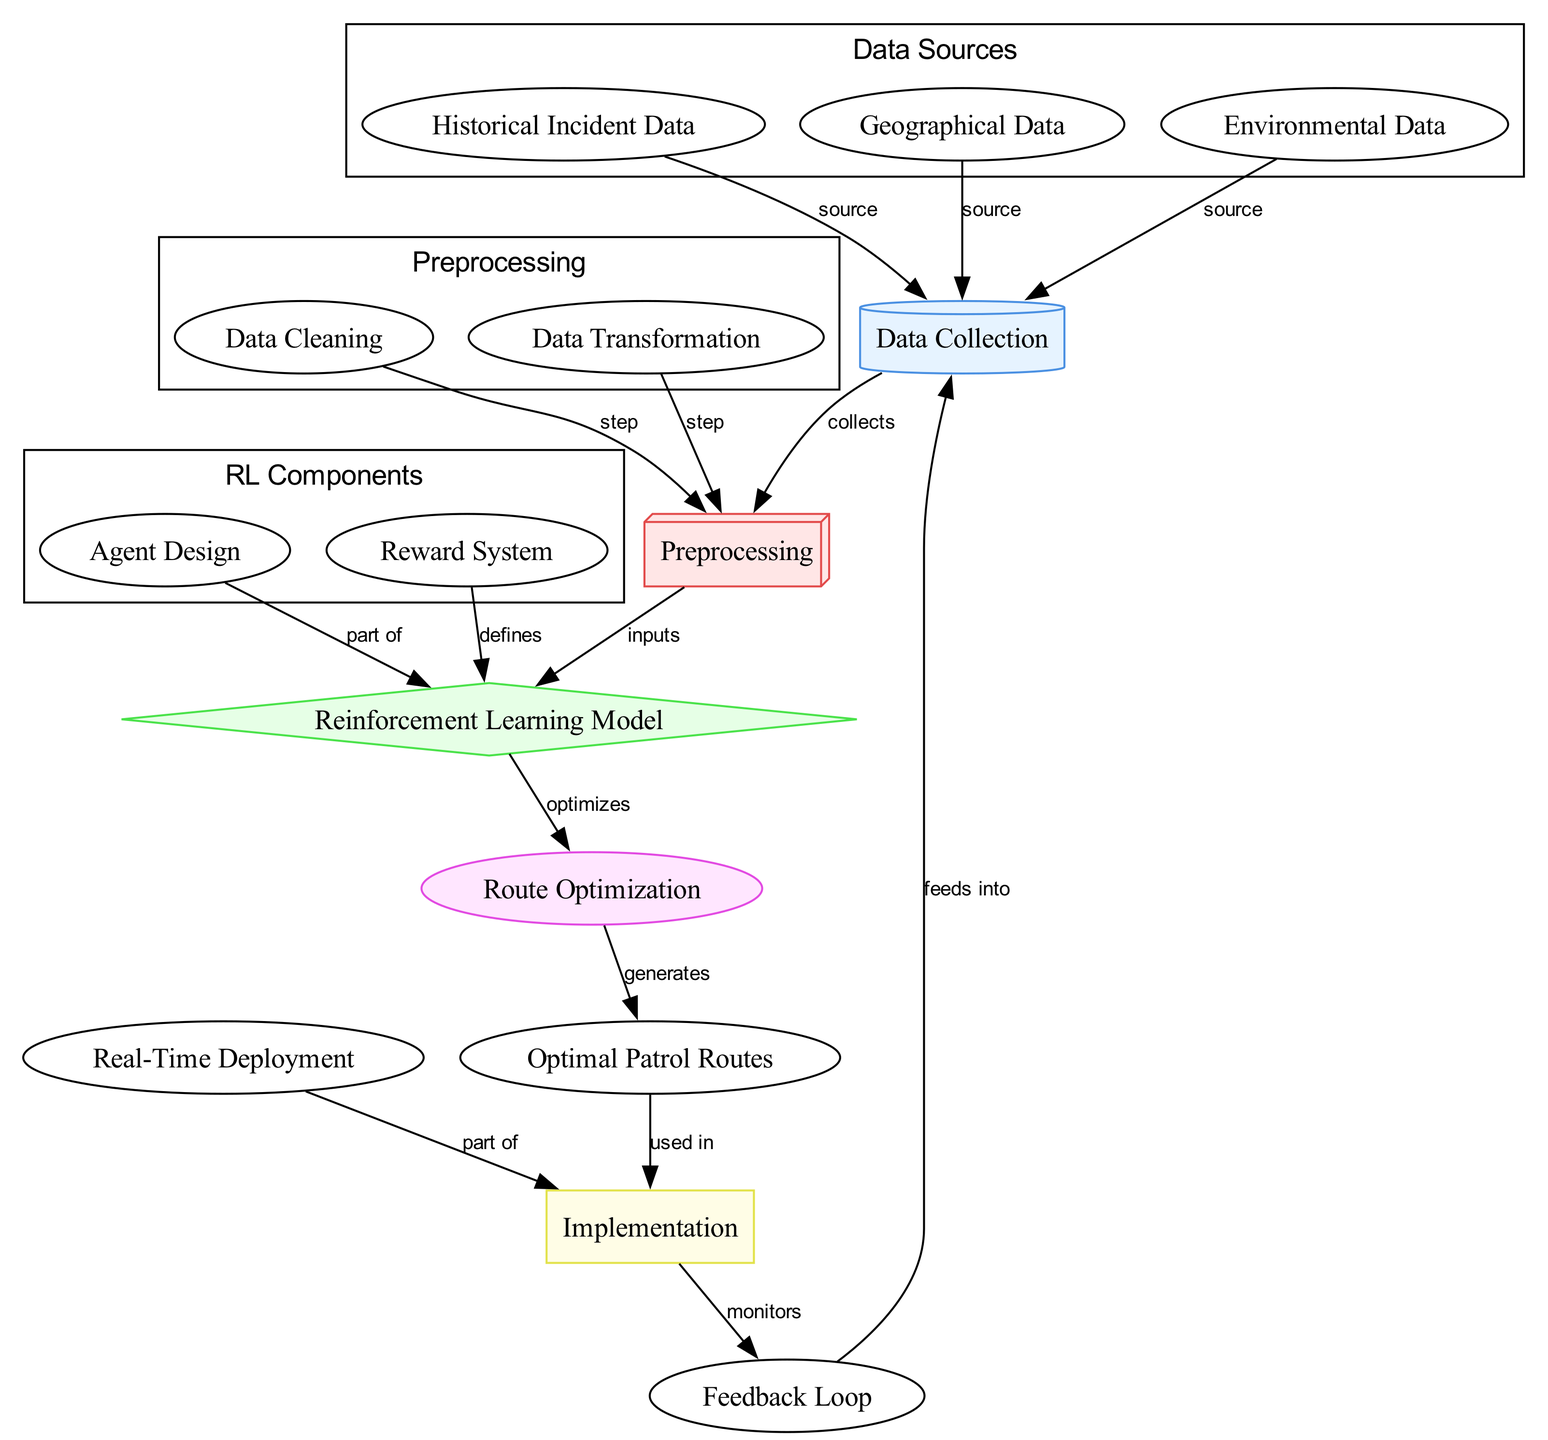What are the three data sources in the diagram? The diagram indicates three data sources which are historical incidents, geographical data, and environmental data. These nodes are categorized under the "Data Sources" subgraph.
Answer: historical incidents, geographical data, environmental data What is the first step after data collection? According to the diagram, after data collection, the next step is preprocessing, which is directly connected to the data collection node.
Answer: preprocessing How many nodes are in the diagram? By counting the nodes listed in the data, there are a total of 13 nodes present in the diagram.
Answer: 13 What role does the reward system play in the reinforcement learning model? The reward system is defined as a component of the reinforcement learning model, as indicated by the edge connecting these two nodes.
Answer: defines Which component generates optimal patrol routes? The optimal patrol routes are generated as a result of the route optimization process, which is optimized by the reinforcement learning model.
Answer: route optimization What feeds back into the data collection? The feedback loop is shown to feed into the data collection, indicating a cyclical relationship for improvement or adjustment based on ongoing data.
Answer: feedback loop How many edges are directed towards preprocessing? There are three edges directed towards the preprocessing node: data cleaning, data transformation, and data collection. Each edge represents a step or source contributing to preprocessing.
Answer: 3 What is used in the implementation phase? The patrol routes generated from the route optimization phase are directly labeled as being used in the implementation phase.
Answer: optimal patrol routes What is a part of the reinforcement learning model? Agent design is labeled as part of the reinforcement learning model, suggesting its importance in the overall system design for route optimization.
Answer: agent design 